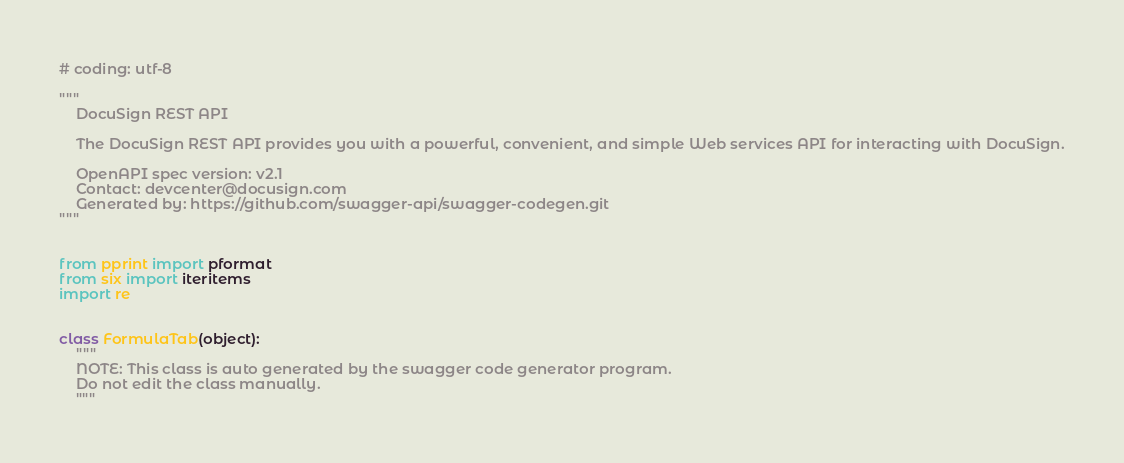<code> <loc_0><loc_0><loc_500><loc_500><_Python_># coding: utf-8

"""
    DocuSign REST API

    The DocuSign REST API provides you with a powerful, convenient, and simple Web services API for interacting with DocuSign.

    OpenAPI spec version: v2.1
    Contact: devcenter@docusign.com
    Generated by: https://github.com/swagger-api/swagger-codegen.git
"""


from pprint import pformat
from six import iteritems
import re


class FormulaTab(object):
    """
    NOTE: This class is auto generated by the swagger code generator program.
    Do not edit the class manually.
    """</code> 